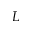Convert formula to latex. <formula><loc_0><loc_0><loc_500><loc_500>_ { L }</formula> 